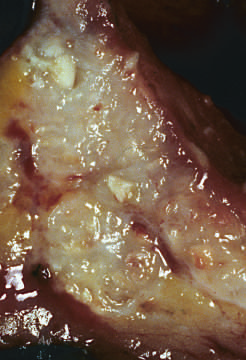re areas of chalky necrosis present within the colon wall?
Answer the question using a single word or phrase. Yes 